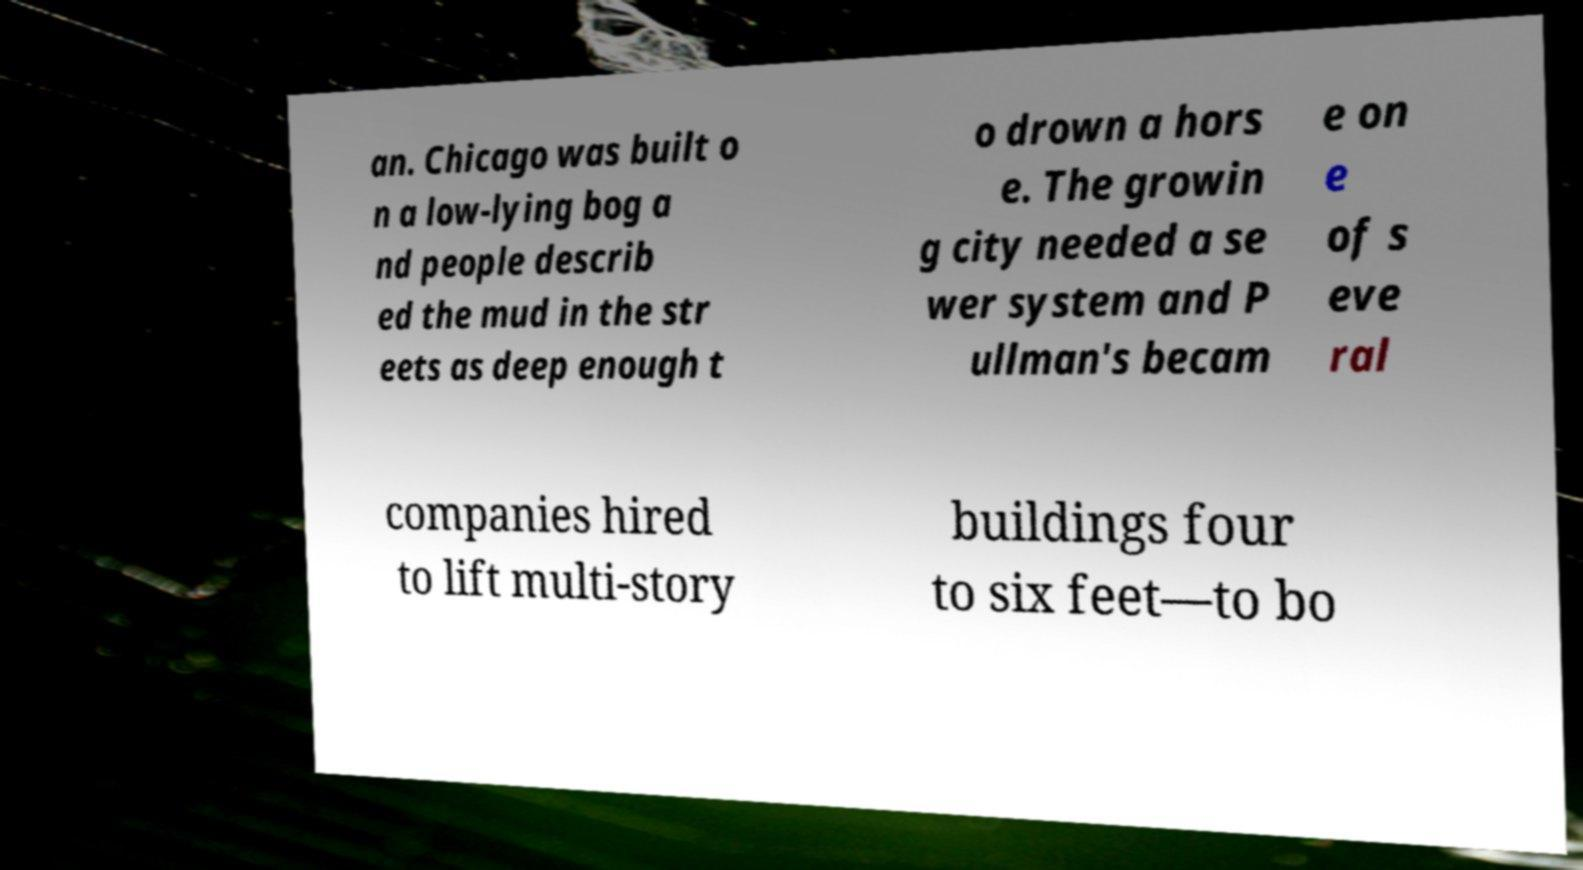For documentation purposes, I need the text within this image transcribed. Could you provide that? an. Chicago was built o n a low-lying bog a nd people describ ed the mud in the str eets as deep enough t o drown a hors e. The growin g city needed a se wer system and P ullman's becam e on e of s eve ral companies hired to lift multi-story buildings four to six feet—to bo 